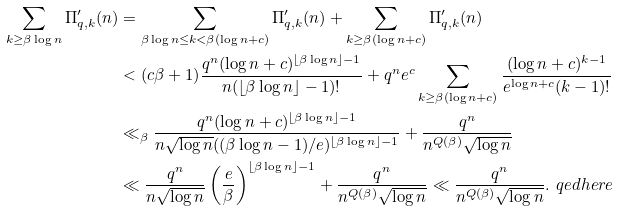<formula> <loc_0><loc_0><loc_500><loc_500>\sum _ { k \geq \beta \log n } \Pi ^ { \prime } _ { q , k } ( n ) & = \sum _ { \beta \log n \leq k < \beta ( \log n + c ) } \Pi ^ { \prime } _ { q , k } ( n ) + \sum _ { k \geq \beta ( \log n + c ) } \Pi ^ { \prime } _ { q , k } ( n ) \\ & < ( c \beta + 1 ) \frac { q ^ { n } ( \log n + c ) ^ { \lfloor \beta \log n \rfloor - 1 } } { n ( \lfloor \beta \log n \rfloor - 1 ) ! } + q ^ { n } e ^ { c } \sum _ { k \geq \beta ( \log n + c ) } \frac { ( \log n + c ) ^ { k - 1 } } { e ^ { \log n + c } ( k - 1 ) ! } \\ & \ll _ { \beta } \frac { q ^ { n } ( \log n + c ) ^ { \lfloor \beta \log n \rfloor - 1 } } { n \sqrt { \log n } ( ( \beta \log n - 1 ) / e ) ^ { \lfloor \beta \log n \rfloor - 1 } } + \frac { q ^ { n } } { n ^ { Q ( \beta ) } \sqrt { \log n } } \\ & \ll \frac { q ^ { n } } { n \sqrt { \log n } } \left ( \frac { e } { \beta } \right ) ^ { \lfloor \beta \log n \rfloor - 1 } + \frac { q ^ { n } } { n ^ { Q ( \beta ) } \sqrt { \log n } } \ll \frac { q ^ { n } } { n ^ { Q ( \beta ) } \sqrt { \log n } } . \ q e d h e r e</formula> 